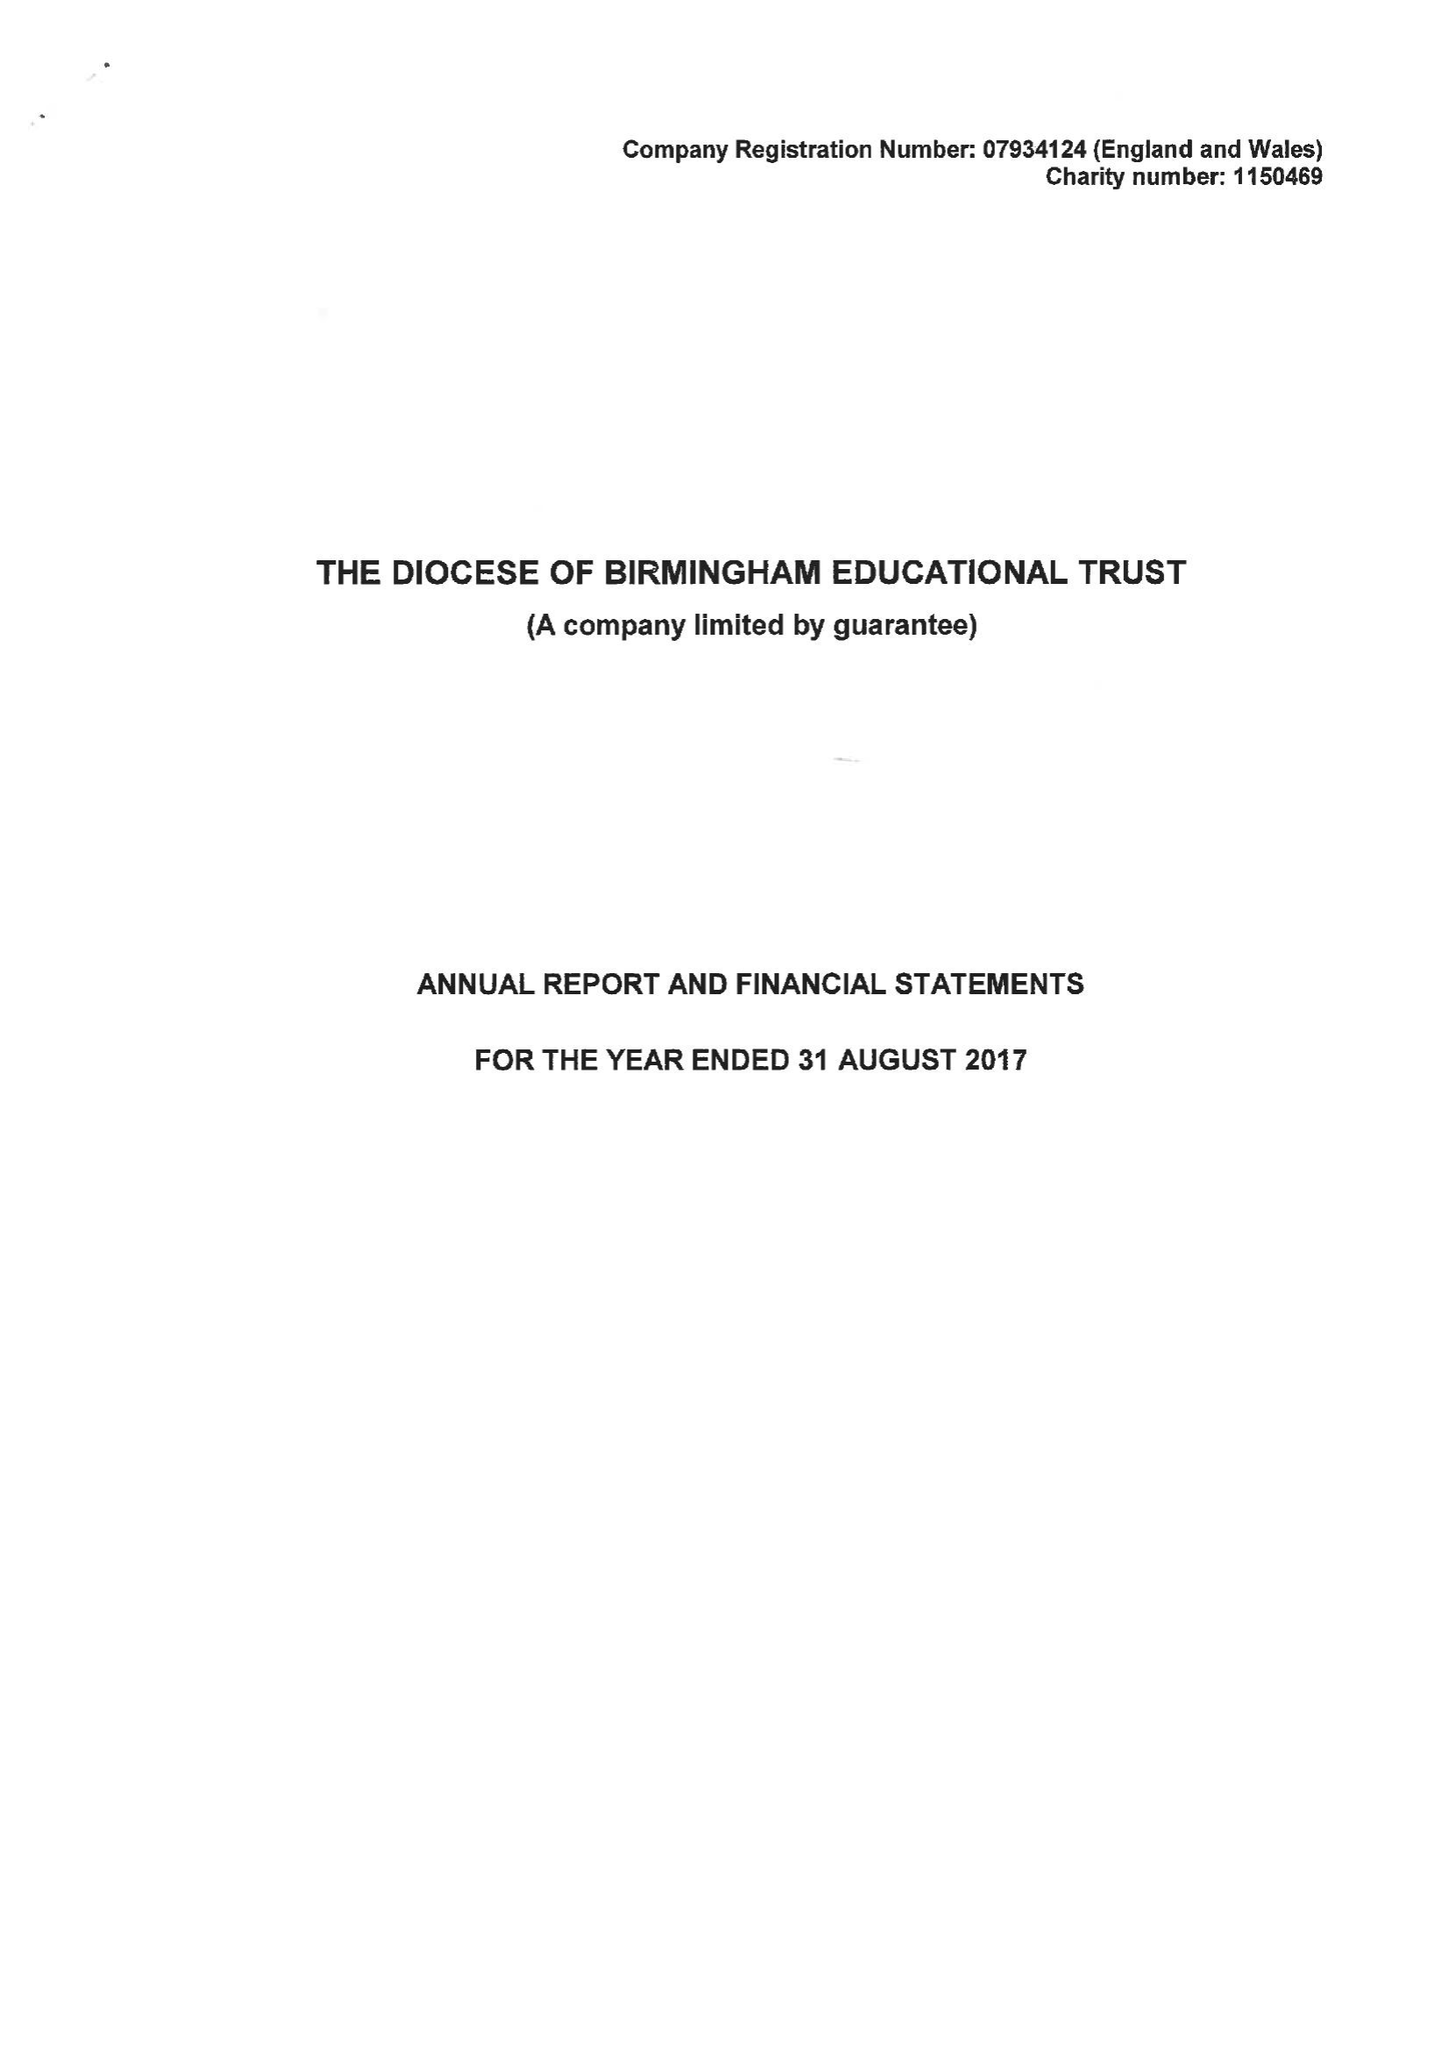What is the value for the spending_annually_in_british_pounds?
Answer the question using a single word or phrase. 263882.00 